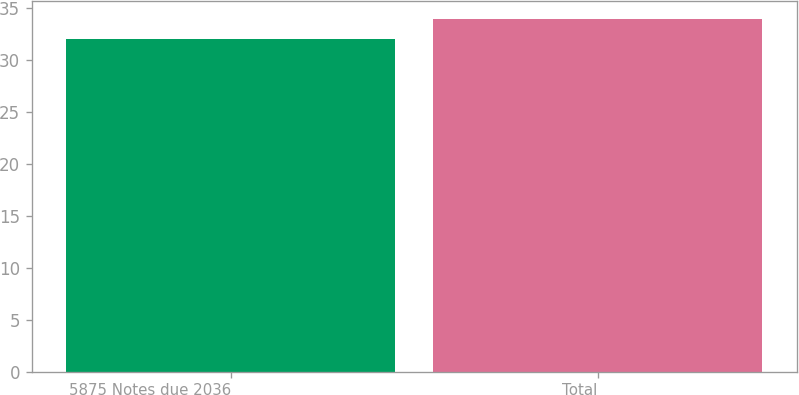<chart> <loc_0><loc_0><loc_500><loc_500><bar_chart><fcel>5875 Notes due 2036<fcel>Total<nl><fcel>32<fcel>34<nl></chart> 